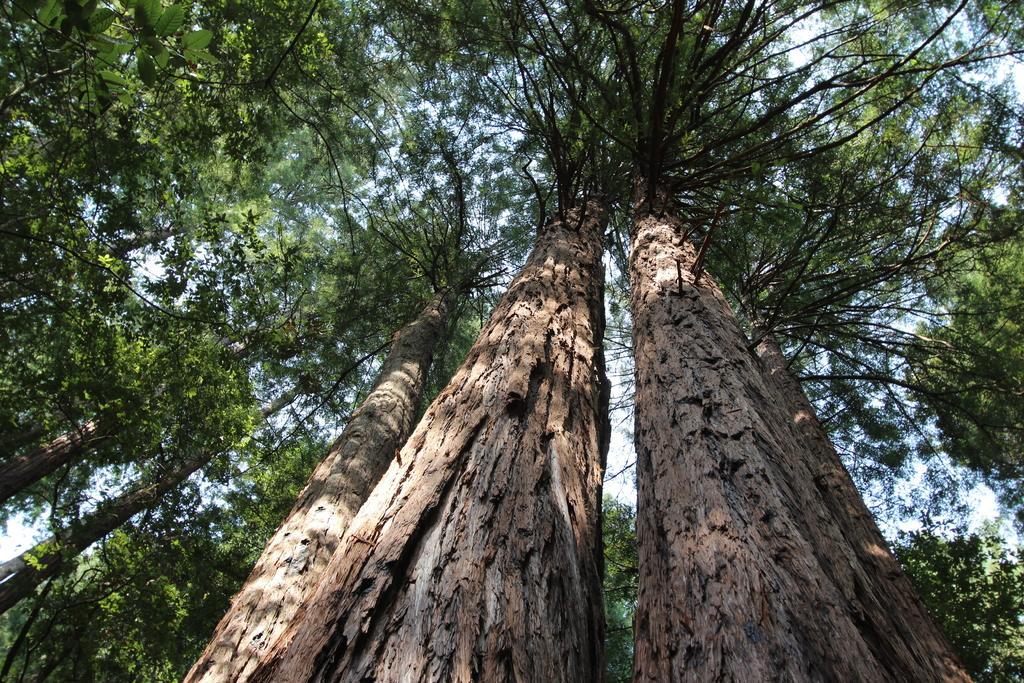Can you describe this image briefly? In this picture I can see trees, and in the background there is the sky. 